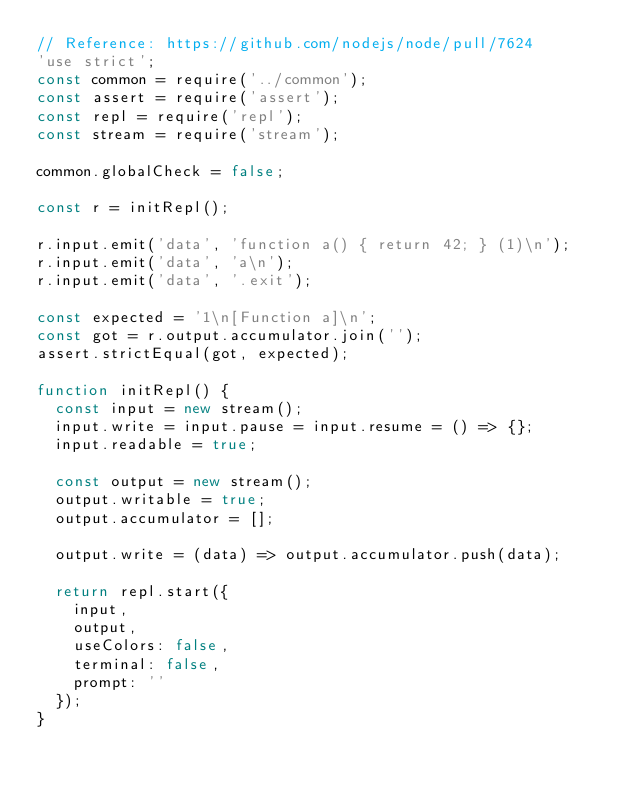<code> <loc_0><loc_0><loc_500><loc_500><_JavaScript_>// Reference: https://github.com/nodejs/node/pull/7624
'use strict';
const common = require('../common');
const assert = require('assert');
const repl = require('repl');
const stream = require('stream');

common.globalCheck = false;

const r = initRepl();

r.input.emit('data', 'function a() { return 42; } (1)\n');
r.input.emit('data', 'a\n');
r.input.emit('data', '.exit');

const expected = '1\n[Function a]\n';
const got = r.output.accumulator.join('');
assert.strictEqual(got, expected);

function initRepl() {
  const input = new stream();
  input.write = input.pause = input.resume = () => {};
  input.readable = true;

  const output = new stream();
  output.writable = true;
  output.accumulator = [];

  output.write = (data) => output.accumulator.push(data);

  return repl.start({
    input,
    output,
    useColors: false,
    terminal: false,
    prompt: ''
  });
}
</code> 